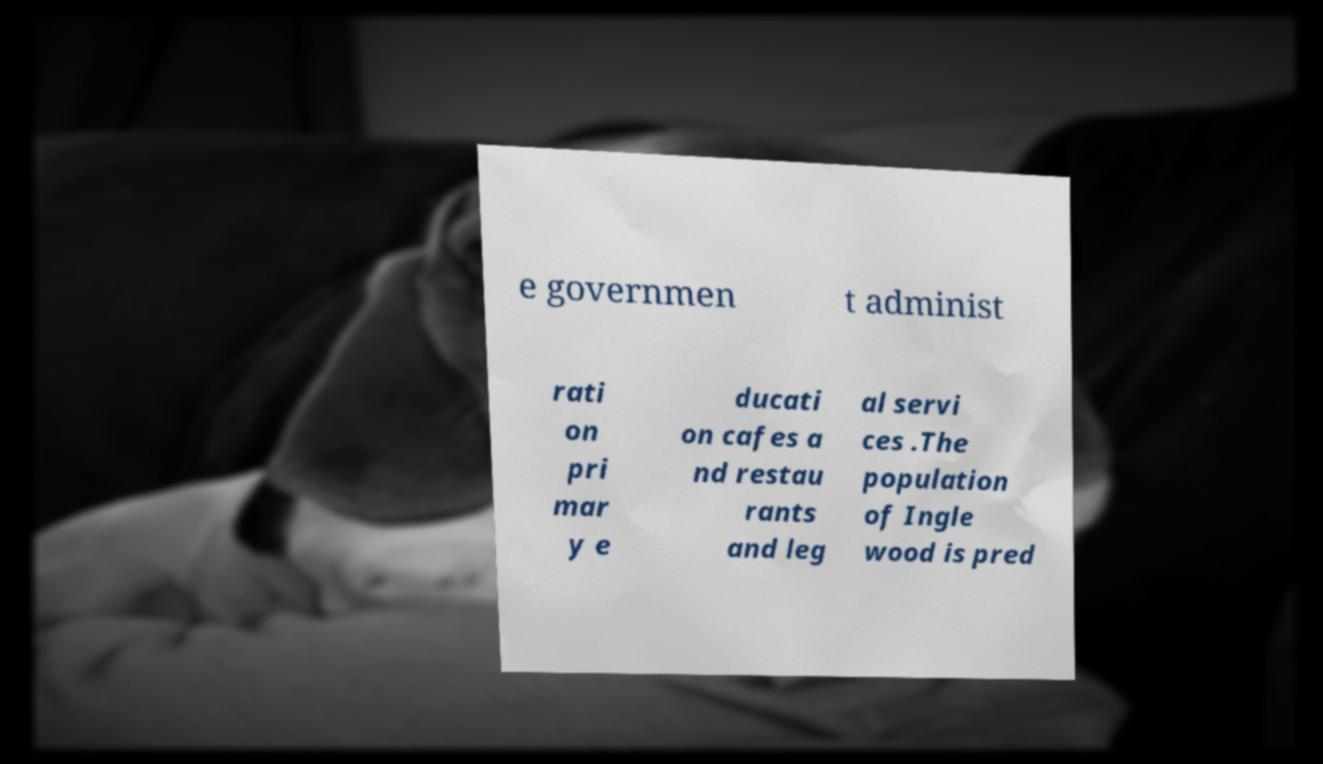Please identify and transcribe the text found in this image. e governmen t administ rati on pri mar y e ducati on cafes a nd restau rants and leg al servi ces .The population of Ingle wood is pred 